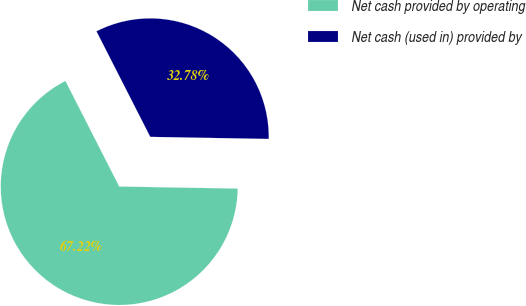Convert chart to OTSL. <chart><loc_0><loc_0><loc_500><loc_500><pie_chart><fcel>Net cash provided by operating<fcel>Net cash (used in) provided by<nl><fcel>67.22%<fcel>32.78%<nl></chart> 